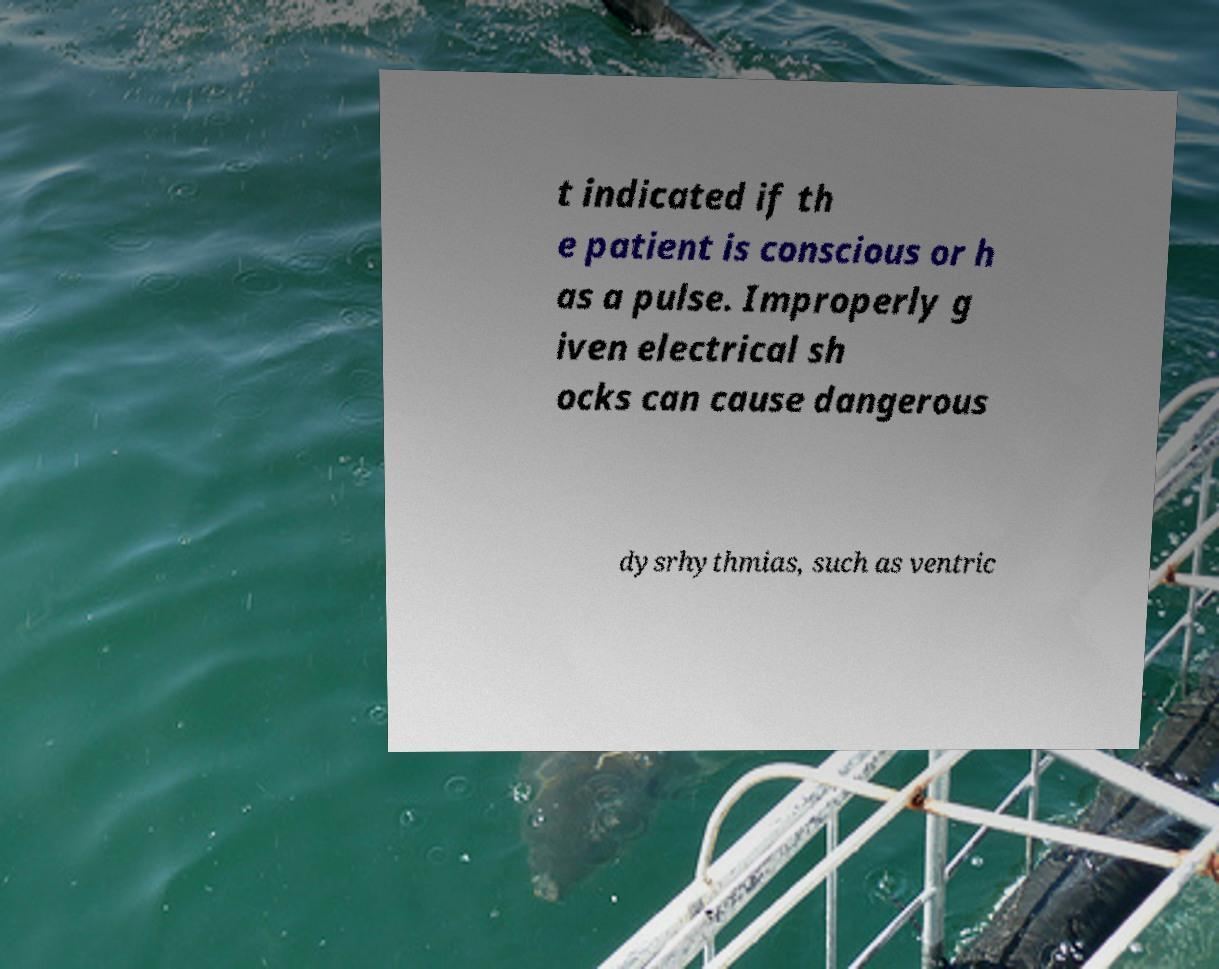Could you assist in decoding the text presented in this image and type it out clearly? t indicated if th e patient is conscious or h as a pulse. Improperly g iven electrical sh ocks can cause dangerous dysrhythmias, such as ventric 